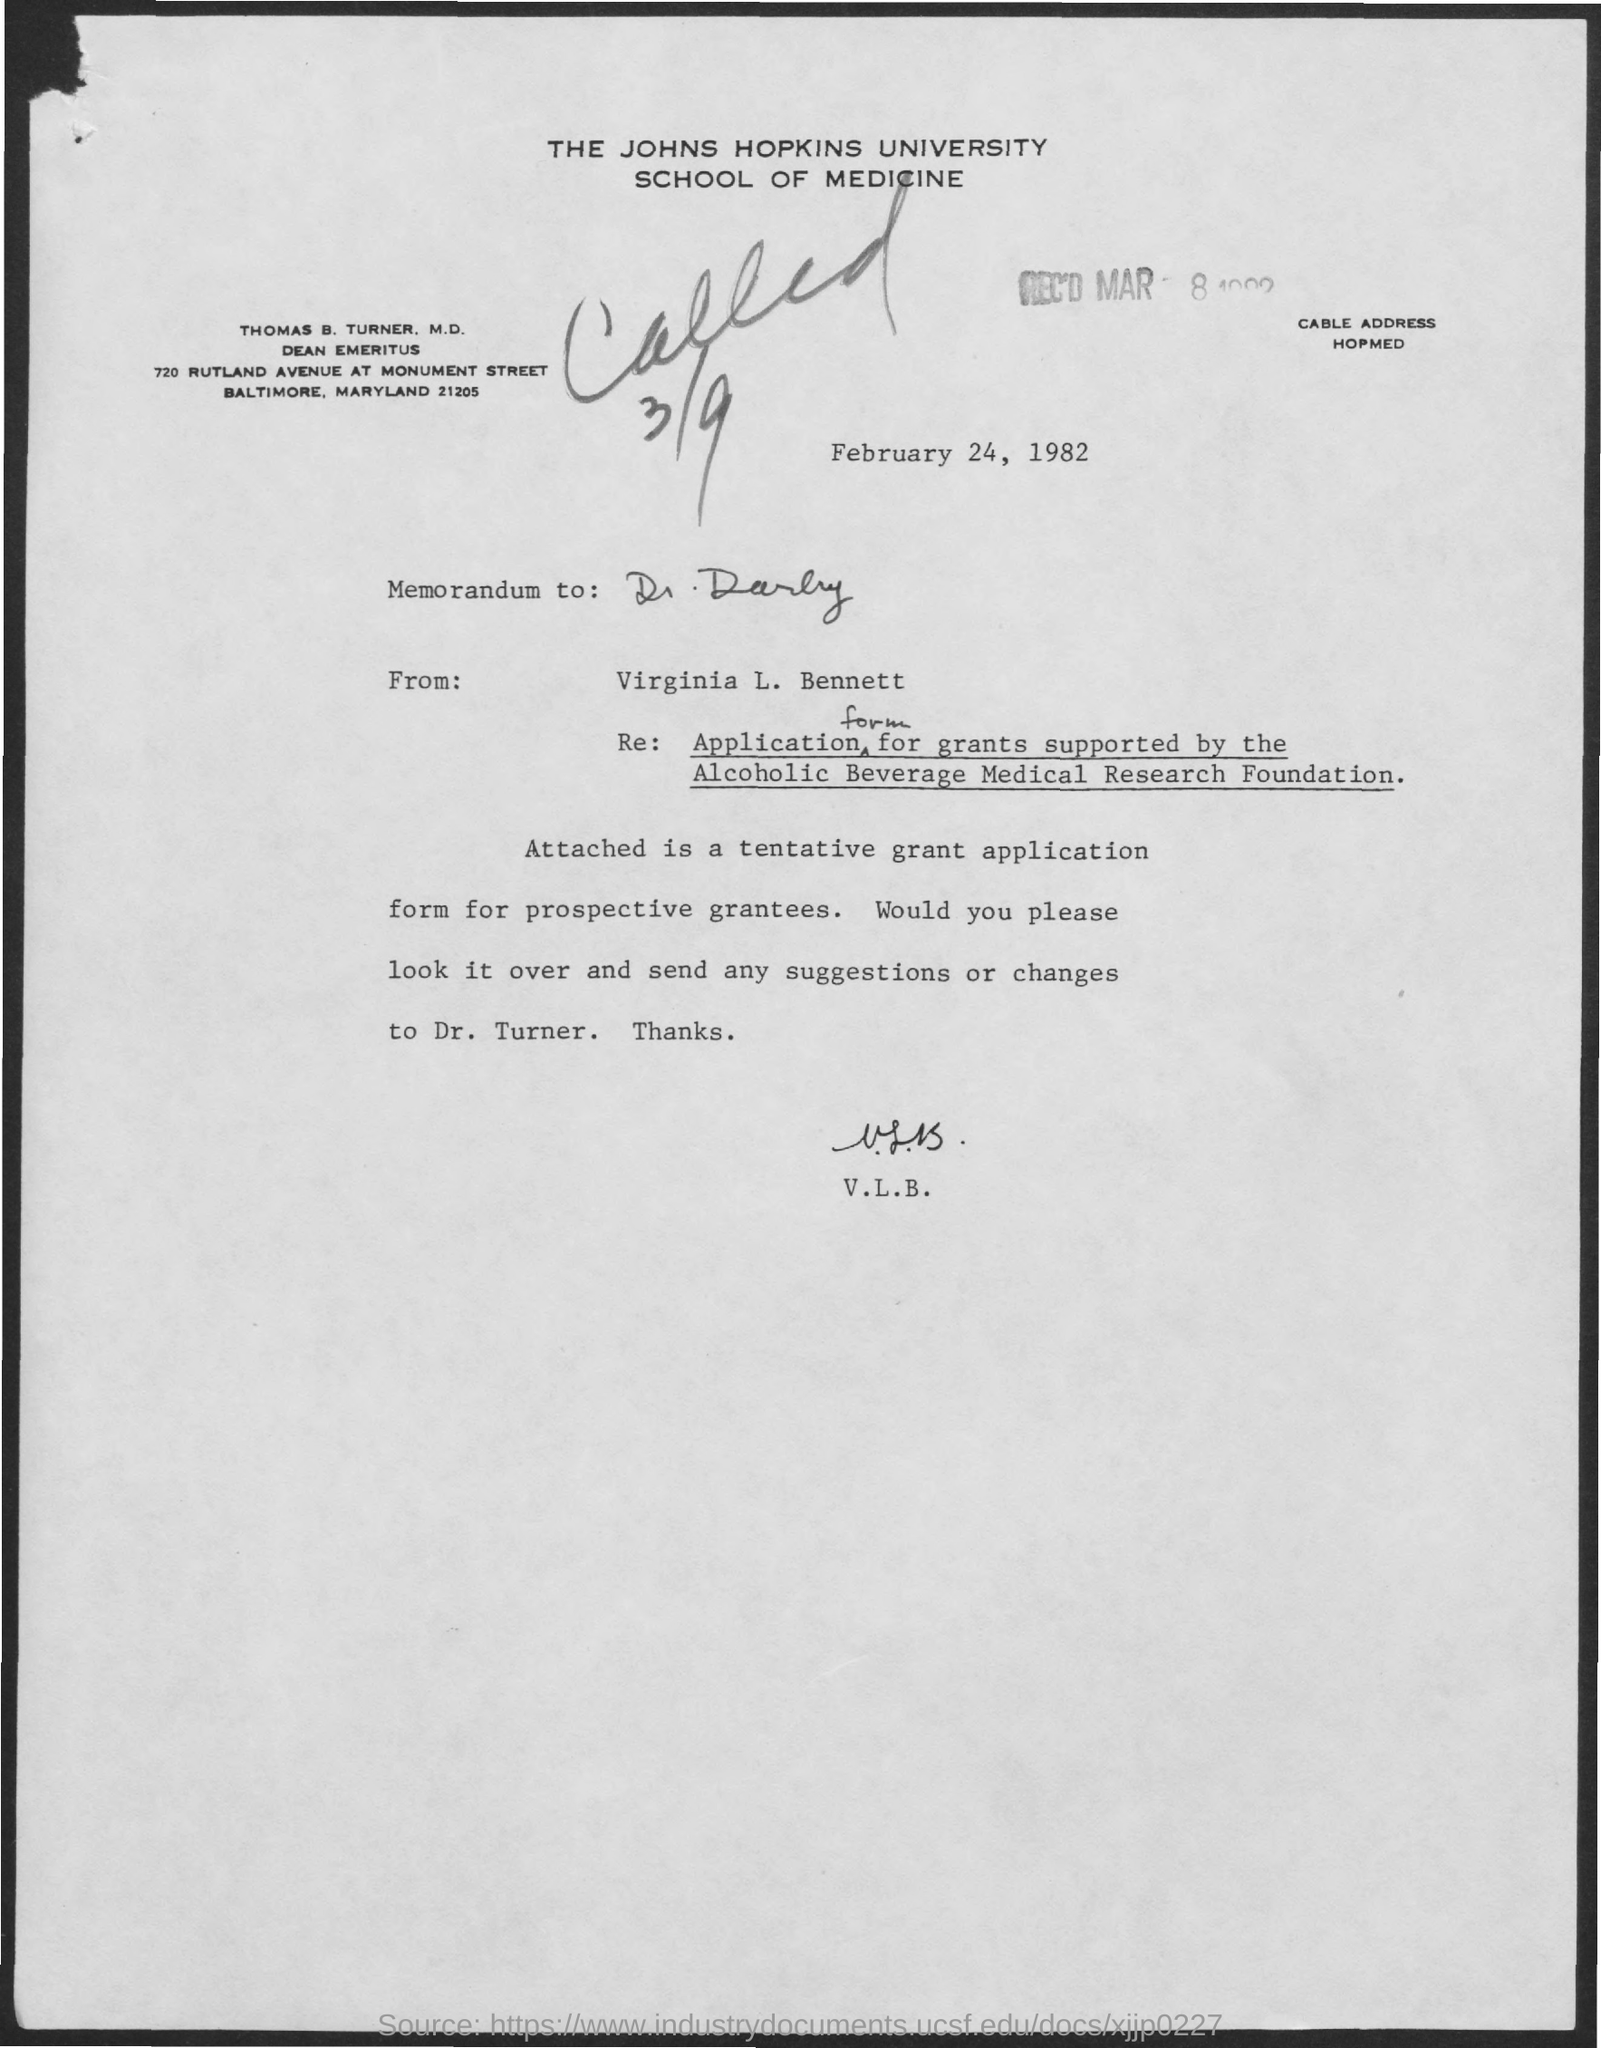Point out several critical features in this image. The letterhead contains the text 'What is written in the letter head ? the johns Hopkins university..'. The memorandum is dated February 24, 1982. 